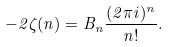<formula> <loc_0><loc_0><loc_500><loc_500>- 2 \zeta ( n ) = B _ { n } \frac { ( 2 \pi i ) ^ { n } } { n ! } .</formula> 